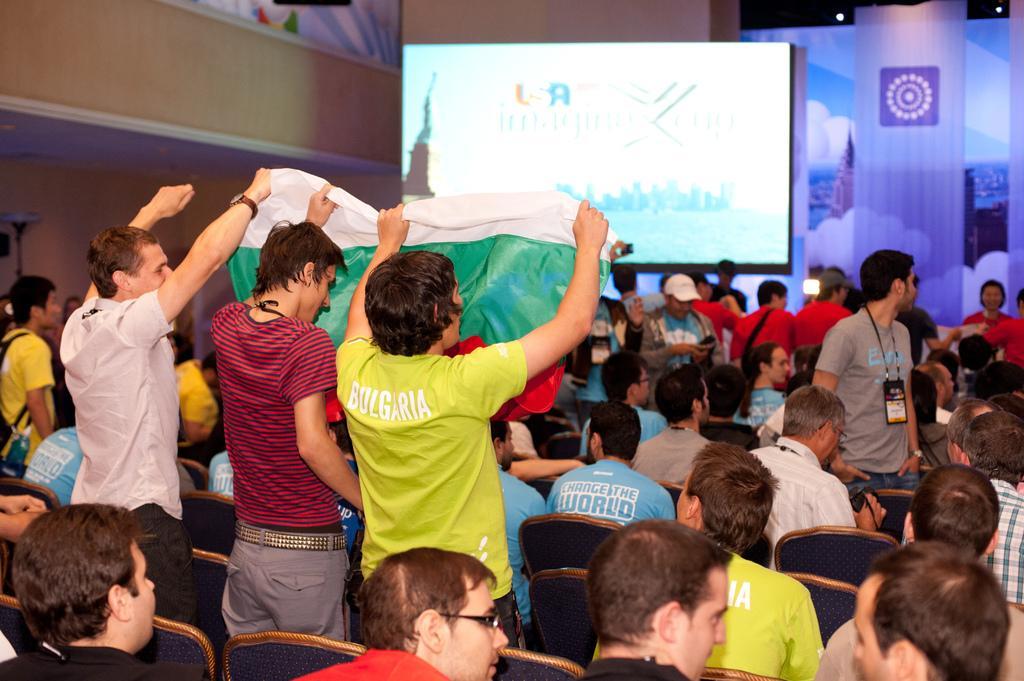Can you describe this image briefly? In this picture we can see a group of people sitting on chairs and three people are holding a flag with their hands and some people are standing and in the background we can see a screen, walls, lights and some objects. 